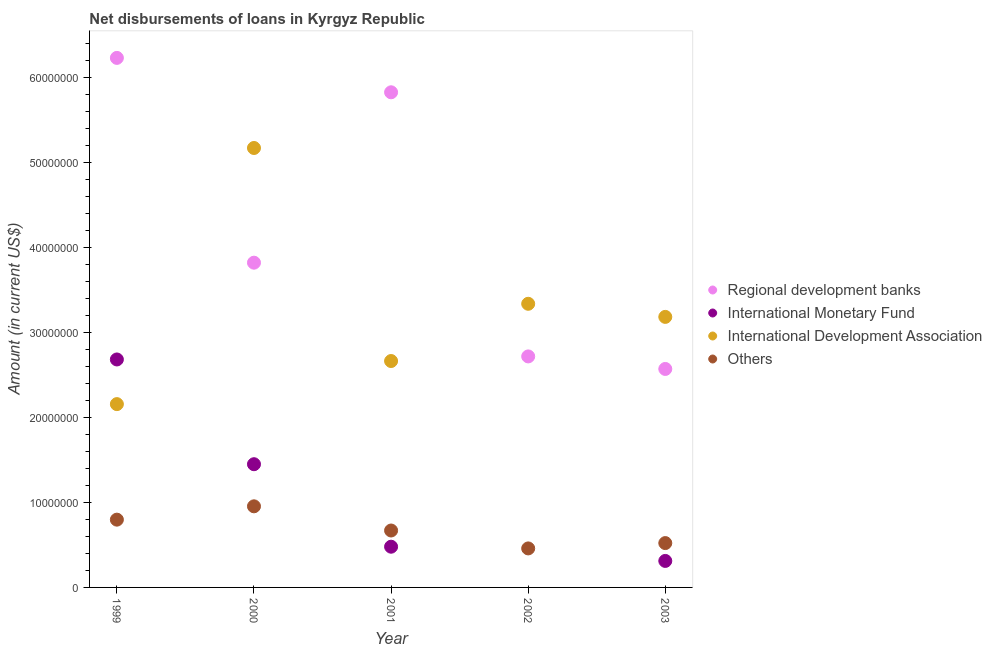What is the amount of loan disimbursed by international development association in 2002?
Ensure brevity in your answer.  3.34e+07. Across all years, what is the maximum amount of loan disimbursed by international monetary fund?
Provide a succinct answer. 2.68e+07. Across all years, what is the minimum amount of loan disimbursed by international monetary fund?
Your response must be concise. 0. What is the total amount of loan disimbursed by international development association in the graph?
Ensure brevity in your answer.  1.65e+08. What is the difference between the amount of loan disimbursed by regional development banks in 2002 and that in 2003?
Your answer should be compact. 1.48e+06. What is the difference between the amount of loan disimbursed by international monetary fund in 2001 and the amount of loan disimbursed by international development association in 2002?
Provide a succinct answer. -2.86e+07. What is the average amount of loan disimbursed by international monetary fund per year?
Keep it short and to the point. 9.85e+06. In the year 2002, what is the difference between the amount of loan disimbursed by other organisations and amount of loan disimbursed by international development association?
Your answer should be compact. -2.88e+07. What is the ratio of the amount of loan disimbursed by international development association in 2001 to that in 2003?
Your answer should be compact. 0.84. What is the difference between the highest and the second highest amount of loan disimbursed by other organisations?
Make the answer very short. 1.57e+06. What is the difference between the highest and the lowest amount of loan disimbursed by international development association?
Make the answer very short. 3.02e+07. In how many years, is the amount of loan disimbursed by international monetary fund greater than the average amount of loan disimbursed by international monetary fund taken over all years?
Your answer should be very brief. 2. Is the sum of the amount of loan disimbursed by other organisations in 1999 and 2002 greater than the maximum amount of loan disimbursed by regional development banks across all years?
Offer a very short reply. No. Does the amount of loan disimbursed by international development association monotonically increase over the years?
Give a very brief answer. No. Is the amount of loan disimbursed by international development association strictly greater than the amount of loan disimbursed by regional development banks over the years?
Offer a terse response. No. How many years are there in the graph?
Ensure brevity in your answer.  5. What is the difference between two consecutive major ticks on the Y-axis?
Provide a short and direct response. 1.00e+07. Are the values on the major ticks of Y-axis written in scientific E-notation?
Your answer should be very brief. No. Does the graph contain any zero values?
Ensure brevity in your answer.  Yes. Does the graph contain grids?
Provide a succinct answer. No. What is the title of the graph?
Keep it short and to the point. Net disbursements of loans in Kyrgyz Republic. What is the label or title of the Y-axis?
Ensure brevity in your answer.  Amount (in current US$). What is the Amount (in current US$) of Regional development banks in 1999?
Your answer should be very brief. 6.24e+07. What is the Amount (in current US$) of International Monetary Fund in 1999?
Your answer should be compact. 2.68e+07. What is the Amount (in current US$) in International Development Association in 1999?
Your answer should be compact. 2.16e+07. What is the Amount (in current US$) in Others in 1999?
Provide a short and direct response. 7.98e+06. What is the Amount (in current US$) in Regional development banks in 2000?
Provide a short and direct response. 3.82e+07. What is the Amount (in current US$) in International Monetary Fund in 2000?
Your answer should be very brief. 1.45e+07. What is the Amount (in current US$) of International Development Association in 2000?
Ensure brevity in your answer.  5.17e+07. What is the Amount (in current US$) in Others in 2000?
Your answer should be very brief. 9.55e+06. What is the Amount (in current US$) in Regional development banks in 2001?
Your answer should be very brief. 5.83e+07. What is the Amount (in current US$) in International Monetary Fund in 2001?
Make the answer very short. 4.79e+06. What is the Amount (in current US$) in International Development Association in 2001?
Provide a short and direct response. 2.67e+07. What is the Amount (in current US$) of Others in 2001?
Your response must be concise. 6.70e+06. What is the Amount (in current US$) of Regional development banks in 2002?
Make the answer very short. 2.72e+07. What is the Amount (in current US$) in International Monetary Fund in 2002?
Make the answer very short. 0. What is the Amount (in current US$) of International Development Association in 2002?
Give a very brief answer. 3.34e+07. What is the Amount (in current US$) of Others in 2002?
Provide a short and direct response. 4.59e+06. What is the Amount (in current US$) of Regional development banks in 2003?
Keep it short and to the point. 2.57e+07. What is the Amount (in current US$) in International Monetary Fund in 2003?
Give a very brief answer. 3.12e+06. What is the Amount (in current US$) in International Development Association in 2003?
Offer a terse response. 3.19e+07. What is the Amount (in current US$) of Others in 2003?
Offer a very short reply. 5.22e+06. Across all years, what is the maximum Amount (in current US$) in Regional development banks?
Give a very brief answer. 6.24e+07. Across all years, what is the maximum Amount (in current US$) of International Monetary Fund?
Provide a succinct answer. 2.68e+07. Across all years, what is the maximum Amount (in current US$) in International Development Association?
Your answer should be compact. 5.17e+07. Across all years, what is the maximum Amount (in current US$) of Others?
Ensure brevity in your answer.  9.55e+06. Across all years, what is the minimum Amount (in current US$) of Regional development banks?
Provide a short and direct response. 2.57e+07. Across all years, what is the minimum Amount (in current US$) of International Monetary Fund?
Give a very brief answer. 0. Across all years, what is the minimum Amount (in current US$) in International Development Association?
Your answer should be compact. 2.16e+07. Across all years, what is the minimum Amount (in current US$) of Others?
Offer a very short reply. 4.59e+06. What is the total Amount (in current US$) in Regional development banks in the graph?
Keep it short and to the point. 2.12e+08. What is the total Amount (in current US$) of International Monetary Fund in the graph?
Make the answer very short. 4.93e+07. What is the total Amount (in current US$) of International Development Association in the graph?
Ensure brevity in your answer.  1.65e+08. What is the total Amount (in current US$) in Others in the graph?
Give a very brief answer. 3.40e+07. What is the difference between the Amount (in current US$) of Regional development banks in 1999 and that in 2000?
Keep it short and to the point. 2.41e+07. What is the difference between the Amount (in current US$) in International Monetary Fund in 1999 and that in 2000?
Keep it short and to the point. 1.23e+07. What is the difference between the Amount (in current US$) of International Development Association in 1999 and that in 2000?
Your answer should be very brief. -3.02e+07. What is the difference between the Amount (in current US$) of Others in 1999 and that in 2000?
Give a very brief answer. -1.57e+06. What is the difference between the Amount (in current US$) of Regional development banks in 1999 and that in 2001?
Your response must be concise. 4.05e+06. What is the difference between the Amount (in current US$) of International Monetary Fund in 1999 and that in 2001?
Provide a short and direct response. 2.20e+07. What is the difference between the Amount (in current US$) of International Development Association in 1999 and that in 2001?
Ensure brevity in your answer.  -5.07e+06. What is the difference between the Amount (in current US$) of Others in 1999 and that in 2001?
Your answer should be very brief. 1.28e+06. What is the difference between the Amount (in current US$) in Regional development banks in 1999 and that in 2002?
Provide a succinct answer. 3.52e+07. What is the difference between the Amount (in current US$) of International Development Association in 1999 and that in 2002?
Give a very brief answer. -1.18e+07. What is the difference between the Amount (in current US$) of Others in 1999 and that in 2002?
Keep it short and to the point. 3.39e+06. What is the difference between the Amount (in current US$) of Regional development banks in 1999 and that in 2003?
Provide a short and direct response. 3.66e+07. What is the difference between the Amount (in current US$) in International Monetary Fund in 1999 and that in 2003?
Provide a short and direct response. 2.37e+07. What is the difference between the Amount (in current US$) in International Development Association in 1999 and that in 2003?
Give a very brief answer. -1.03e+07. What is the difference between the Amount (in current US$) in Others in 1999 and that in 2003?
Ensure brevity in your answer.  2.76e+06. What is the difference between the Amount (in current US$) of Regional development banks in 2000 and that in 2001?
Give a very brief answer. -2.01e+07. What is the difference between the Amount (in current US$) of International Monetary Fund in 2000 and that in 2001?
Your response must be concise. 9.71e+06. What is the difference between the Amount (in current US$) in International Development Association in 2000 and that in 2001?
Offer a terse response. 2.51e+07. What is the difference between the Amount (in current US$) in Others in 2000 and that in 2001?
Ensure brevity in your answer.  2.85e+06. What is the difference between the Amount (in current US$) of Regional development banks in 2000 and that in 2002?
Your response must be concise. 1.10e+07. What is the difference between the Amount (in current US$) of International Development Association in 2000 and that in 2002?
Give a very brief answer. 1.83e+07. What is the difference between the Amount (in current US$) of Others in 2000 and that in 2002?
Provide a succinct answer. 4.96e+06. What is the difference between the Amount (in current US$) in Regional development banks in 2000 and that in 2003?
Your response must be concise. 1.25e+07. What is the difference between the Amount (in current US$) of International Monetary Fund in 2000 and that in 2003?
Your answer should be compact. 1.14e+07. What is the difference between the Amount (in current US$) of International Development Association in 2000 and that in 2003?
Your answer should be very brief. 1.99e+07. What is the difference between the Amount (in current US$) in Others in 2000 and that in 2003?
Provide a succinct answer. 4.33e+06. What is the difference between the Amount (in current US$) in Regional development banks in 2001 and that in 2002?
Give a very brief answer. 3.11e+07. What is the difference between the Amount (in current US$) of International Development Association in 2001 and that in 2002?
Make the answer very short. -6.74e+06. What is the difference between the Amount (in current US$) of Others in 2001 and that in 2002?
Your answer should be compact. 2.11e+06. What is the difference between the Amount (in current US$) in Regional development banks in 2001 and that in 2003?
Provide a short and direct response. 3.26e+07. What is the difference between the Amount (in current US$) in International Monetary Fund in 2001 and that in 2003?
Give a very brief answer. 1.67e+06. What is the difference between the Amount (in current US$) in International Development Association in 2001 and that in 2003?
Offer a very short reply. -5.20e+06. What is the difference between the Amount (in current US$) in Others in 2001 and that in 2003?
Provide a short and direct response. 1.48e+06. What is the difference between the Amount (in current US$) of Regional development banks in 2002 and that in 2003?
Offer a very short reply. 1.48e+06. What is the difference between the Amount (in current US$) of International Development Association in 2002 and that in 2003?
Give a very brief answer. 1.54e+06. What is the difference between the Amount (in current US$) of Others in 2002 and that in 2003?
Give a very brief answer. -6.28e+05. What is the difference between the Amount (in current US$) in Regional development banks in 1999 and the Amount (in current US$) in International Monetary Fund in 2000?
Offer a terse response. 4.78e+07. What is the difference between the Amount (in current US$) of Regional development banks in 1999 and the Amount (in current US$) of International Development Association in 2000?
Make the answer very short. 1.06e+07. What is the difference between the Amount (in current US$) of Regional development banks in 1999 and the Amount (in current US$) of Others in 2000?
Offer a very short reply. 5.28e+07. What is the difference between the Amount (in current US$) in International Monetary Fund in 1999 and the Amount (in current US$) in International Development Association in 2000?
Provide a short and direct response. -2.49e+07. What is the difference between the Amount (in current US$) of International Monetary Fund in 1999 and the Amount (in current US$) of Others in 2000?
Provide a short and direct response. 1.73e+07. What is the difference between the Amount (in current US$) of International Development Association in 1999 and the Amount (in current US$) of Others in 2000?
Give a very brief answer. 1.20e+07. What is the difference between the Amount (in current US$) of Regional development banks in 1999 and the Amount (in current US$) of International Monetary Fund in 2001?
Your answer should be very brief. 5.76e+07. What is the difference between the Amount (in current US$) of Regional development banks in 1999 and the Amount (in current US$) of International Development Association in 2001?
Your answer should be compact. 3.57e+07. What is the difference between the Amount (in current US$) of Regional development banks in 1999 and the Amount (in current US$) of Others in 2001?
Provide a succinct answer. 5.56e+07. What is the difference between the Amount (in current US$) in International Monetary Fund in 1999 and the Amount (in current US$) in International Development Association in 2001?
Ensure brevity in your answer.  1.84e+05. What is the difference between the Amount (in current US$) of International Monetary Fund in 1999 and the Amount (in current US$) of Others in 2001?
Provide a short and direct response. 2.01e+07. What is the difference between the Amount (in current US$) of International Development Association in 1999 and the Amount (in current US$) of Others in 2001?
Offer a terse response. 1.49e+07. What is the difference between the Amount (in current US$) of Regional development banks in 1999 and the Amount (in current US$) of International Development Association in 2002?
Provide a succinct answer. 2.90e+07. What is the difference between the Amount (in current US$) in Regional development banks in 1999 and the Amount (in current US$) in Others in 2002?
Offer a very short reply. 5.78e+07. What is the difference between the Amount (in current US$) of International Monetary Fund in 1999 and the Amount (in current US$) of International Development Association in 2002?
Your response must be concise. -6.56e+06. What is the difference between the Amount (in current US$) in International Monetary Fund in 1999 and the Amount (in current US$) in Others in 2002?
Provide a succinct answer. 2.22e+07. What is the difference between the Amount (in current US$) in International Development Association in 1999 and the Amount (in current US$) in Others in 2002?
Provide a succinct answer. 1.70e+07. What is the difference between the Amount (in current US$) of Regional development banks in 1999 and the Amount (in current US$) of International Monetary Fund in 2003?
Give a very brief answer. 5.92e+07. What is the difference between the Amount (in current US$) of Regional development banks in 1999 and the Amount (in current US$) of International Development Association in 2003?
Keep it short and to the point. 3.05e+07. What is the difference between the Amount (in current US$) in Regional development banks in 1999 and the Amount (in current US$) in Others in 2003?
Give a very brief answer. 5.71e+07. What is the difference between the Amount (in current US$) in International Monetary Fund in 1999 and the Amount (in current US$) in International Development Association in 2003?
Offer a very short reply. -5.01e+06. What is the difference between the Amount (in current US$) of International Monetary Fund in 1999 and the Amount (in current US$) of Others in 2003?
Your response must be concise. 2.16e+07. What is the difference between the Amount (in current US$) of International Development Association in 1999 and the Amount (in current US$) of Others in 2003?
Offer a terse response. 1.64e+07. What is the difference between the Amount (in current US$) in Regional development banks in 2000 and the Amount (in current US$) in International Monetary Fund in 2001?
Ensure brevity in your answer.  3.34e+07. What is the difference between the Amount (in current US$) of Regional development banks in 2000 and the Amount (in current US$) of International Development Association in 2001?
Give a very brief answer. 1.16e+07. What is the difference between the Amount (in current US$) of Regional development banks in 2000 and the Amount (in current US$) of Others in 2001?
Provide a short and direct response. 3.15e+07. What is the difference between the Amount (in current US$) of International Monetary Fund in 2000 and the Amount (in current US$) of International Development Association in 2001?
Provide a short and direct response. -1.22e+07. What is the difference between the Amount (in current US$) in International Monetary Fund in 2000 and the Amount (in current US$) in Others in 2001?
Provide a succinct answer. 7.81e+06. What is the difference between the Amount (in current US$) in International Development Association in 2000 and the Amount (in current US$) in Others in 2001?
Give a very brief answer. 4.50e+07. What is the difference between the Amount (in current US$) in Regional development banks in 2000 and the Amount (in current US$) in International Development Association in 2002?
Offer a terse response. 4.84e+06. What is the difference between the Amount (in current US$) of Regional development banks in 2000 and the Amount (in current US$) of Others in 2002?
Your response must be concise. 3.36e+07. What is the difference between the Amount (in current US$) of International Monetary Fund in 2000 and the Amount (in current US$) of International Development Association in 2002?
Make the answer very short. -1.89e+07. What is the difference between the Amount (in current US$) in International Monetary Fund in 2000 and the Amount (in current US$) in Others in 2002?
Your answer should be very brief. 9.92e+06. What is the difference between the Amount (in current US$) of International Development Association in 2000 and the Amount (in current US$) of Others in 2002?
Your response must be concise. 4.72e+07. What is the difference between the Amount (in current US$) in Regional development banks in 2000 and the Amount (in current US$) in International Monetary Fund in 2003?
Your answer should be very brief. 3.51e+07. What is the difference between the Amount (in current US$) of Regional development banks in 2000 and the Amount (in current US$) of International Development Association in 2003?
Make the answer very short. 6.38e+06. What is the difference between the Amount (in current US$) in Regional development banks in 2000 and the Amount (in current US$) in Others in 2003?
Offer a very short reply. 3.30e+07. What is the difference between the Amount (in current US$) in International Monetary Fund in 2000 and the Amount (in current US$) in International Development Association in 2003?
Your answer should be compact. -1.73e+07. What is the difference between the Amount (in current US$) of International Monetary Fund in 2000 and the Amount (in current US$) of Others in 2003?
Give a very brief answer. 9.29e+06. What is the difference between the Amount (in current US$) in International Development Association in 2000 and the Amount (in current US$) in Others in 2003?
Your response must be concise. 4.65e+07. What is the difference between the Amount (in current US$) in Regional development banks in 2001 and the Amount (in current US$) in International Development Association in 2002?
Your answer should be very brief. 2.49e+07. What is the difference between the Amount (in current US$) in Regional development banks in 2001 and the Amount (in current US$) in Others in 2002?
Ensure brevity in your answer.  5.37e+07. What is the difference between the Amount (in current US$) of International Monetary Fund in 2001 and the Amount (in current US$) of International Development Association in 2002?
Offer a very short reply. -2.86e+07. What is the difference between the Amount (in current US$) in International Monetary Fund in 2001 and the Amount (in current US$) in Others in 2002?
Offer a terse response. 2.01e+05. What is the difference between the Amount (in current US$) of International Development Association in 2001 and the Amount (in current US$) of Others in 2002?
Provide a short and direct response. 2.21e+07. What is the difference between the Amount (in current US$) of Regional development banks in 2001 and the Amount (in current US$) of International Monetary Fund in 2003?
Make the answer very short. 5.52e+07. What is the difference between the Amount (in current US$) in Regional development banks in 2001 and the Amount (in current US$) in International Development Association in 2003?
Provide a succinct answer. 2.64e+07. What is the difference between the Amount (in current US$) in Regional development banks in 2001 and the Amount (in current US$) in Others in 2003?
Keep it short and to the point. 5.31e+07. What is the difference between the Amount (in current US$) in International Monetary Fund in 2001 and the Amount (in current US$) in International Development Association in 2003?
Ensure brevity in your answer.  -2.71e+07. What is the difference between the Amount (in current US$) of International Monetary Fund in 2001 and the Amount (in current US$) of Others in 2003?
Offer a very short reply. -4.27e+05. What is the difference between the Amount (in current US$) of International Development Association in 2001 and the Amount (in current US$) of Others in 2003?
Provide a succinct answer. 2.14e+07. What is the difference between the Amount (in current US$) in Regional development banks in 2002 and the Amount (in current US$) in International Monetary Fund in 2003?
Your answer should be compact. 2.41e+07. What is the difference between the Amount (in current US$) of Regional development banks in 2002 and the Amount (in current US$) of International Development Association in 2003?
Your response must be concise. -4.65e+06. What is the difference between the Amount (in current US$) in Regional development banks in 2002 and the Amount (in current US$) in Others in 2003?
Your answer should be very brief. 2.20e+07. What is the difference between the Amount (in current US$) in International Development Association in 2002 and the Amount (in current US$) in Others in 2003?
Give a very brief answer. 2.82e+07. What is the average Amount (in current US$) of Regional development banks per year?
Your answer should be very brief. 4.24e+07. What is the average Amount (in current US$) in International Monetary Fund per year?
Your answer should be very brief. 9.85e+06. What is the average Amount (in current US$) in International Development Association per year?
Offer a very short reply. 3.30e+07. What is the average Amount (in current US$) of Others per year?
Ensure brevity in your answer.  6.81e+06. In the year 1999, what is the difference between the Amount (in current US$) of Regional development banks and Amount (in current US$) of International Monetary Fund?
Your response must be concise. 3.55e+07. In the year 1999, what is the difference between the Amount (in current US$) in Regional development banks and Amount (in current US$) in International Development Association?
Provide a succinct answer. 4.08e+07. In the year 1999, what is the difference between the Amount (in current US$) of Regional development banks and Amount (in current US$) of Others?
Your response must be concise. 5.44e+07. In the year 1999, what is the difference between the Amount (in current US$) in International Monetary Fund and Amount (in current US$) in International Development Association?
Offer a terse response. 5.26e+06. In the year 1999, what is the difference between the Amount (in current US$) of International Monetary Fund and Amount (in current US$) of Others?
Give a very brief answer. 1.89e+07. In the year 1999, what is the difference between the Amount (in current US$) in International Development Association and Amount (in current US$) in Others?
Provide a short and direct response. 1.36e+07. In the year 2000, what is the difference between the Amount (in current US$) of Regional development banks and Amount (in current US$) of International Monetary Fund?
Keep it short and to the point. 2.37e+07. In the year 2000, what is the difference between the Amount (in current US$) in Regional development banks and Amount (in current US$) in International Development Association?
Ensure brevity in your answer.  -1.35e+07. In the year 2000, what is the difference between the Amount (in current US$) in Regional development banks and Amount (in current US$) in Others?
Your answer should be compact. 2.87e+07. In the year 2000, what is the difference between the Amount (in current US$) of International Monetary Fund and Amount (in current US$) of International Development Association?
Provide a short and direct response. -3.72e+07. In the year 2000, what is the difference between the Amount (in current US$) in International Monetary Fund and Amount (in current US$) in Others?
Ensure brevity in your answer.  4.96e+06. In the year 2000, what is the difference between the Amount (in current US$) of International Development Association and Amount (in current US$) of Others?
Make the answer very short. 4.22e+07. In the year 2001, what is the difference between the Amount (in current US$) in Regional development banks and Amount (in current US$) in International Monetary Fund?
Keep it short and to the point. 5.35e+07. In the year 2001, what is the difference between the Amount (in current US$) of Regional development banks and Amount (in current US$) of International Development Association?
Your answer should be compact. 3.16e+07. In the year 2001, what is the difference between the Amount (in current US$) of Regional development banks and Amount (in current US$) of Others?
Offer a terse response. 5.16e+07. In the year 2001, what is the difference between the Amount (in current US$) of International Monetary Fund and Amount (in current US$) of International Development Association?
Provide a short and direct response. -2.19e+07. In the year 2001, what is the difference between the Amount (in current US$) of International Monetary Fund and Amount (in current US$) of Others?
Make the answer very short. -1.91e+06. In the year 2001, what is the difference between the Amount (in current US$) in International Development Association and Amount (in current US$) in Others?
Your answer should be compact. 2.00e+07. In the year 2002, what is the difference between the Amount (in current US$) of Regional development banks and Amount (in current US$) of International Development Association?
Provide a short and direct response. -6.20e+06. In the year 2002, what is the difference between the Amount (in current US$) of Regional development banks and Amount (in current US$) of Others?
Offer a very short reply. 2.26e+07. In the year 2002, what is the difference between the Amount (in current US$) of International Development Association and Amount (in current US$) of Others?
Ensure brevity in your answer.  2.88e+07. In the year 2003, what is the difference between the Amount (in current US$) of Regional development banks and Amount (in current US$) of International Monetary Fund?
Offer a terse response. 2.26e+07. In the year 2003, what is the difference between the Amount (in current US$) of Regional development banks and Amount (in current US$) of International Development Association?
Provide a short and direct response. -6.13e+06. In the year 2003, what is the difference between the Amount (in current US$) of Regional development banks and Amount (in current US$) of Others?
Provide a short and direct response. 2.05e+07. In the year 2003, what is the difference between the Amount (in current US$) of International Monetary Fund and Amount (in current US$) of International Development Association?
Your answer should be very brief. -2.87e+07. In the year 2003, what is the difference between the Amount (in current US$) in International Monetary Fund and Amount (in current US$) in Others?
Ensure brevity in your answer.  -2.10e+06. In the year 2003, what is the difference between the Amount (in current US$) of International Development Association and Amount (in current US$) of Others?
Offer a terse response. 2.66e+07. What is the ratio of the Amount (in current US$) in Regional development banks in 1999 to that in 2000?
Provide a short and direct response. 1.63. What is the ratio of the Amount (in current US$) in International Monetary Fund in 1999 to that in 2000?
Give a very brief answer. 1.85. What is the ratio of the Amount (in current US$) in International Development Association in 1999 to that in 2000?
Provide a succinct answer. 0.42. What is the ratio of the Amount (in current US$) in Others in 1999 to that in 2000?
Offer a very short reply. 0.84. What is the ratio of the Amount (in current US$) in Regional development banks in 1999 to that in 2001?
Your answer should be very brief. 1.07. What is the ratio of the Amount (in current US$) of International Monetary Fund in 1999 to that in 2001?
Your response must be concise. 5.6. What is the ratio of the Amount (in current US$) of International Development Association in 1999 to that in 2001?
Provide a succinct answer. 0.81. What is the ratio of the Amount (in current US$) in Others in 1999 to that in 2001?
Ensure brevity in your answer.  1.19. What is the ratio of the Amount (in current US$) in Regional development banks in 1999 to that in 2002?
Keep it short and to the point. 2.29. What is the ratio of the Amount (in current US$) in International Development Association in 1999 to that in 2002?
Keep it short and to the point. 0.65. What is the ratio of the Amount (in current US$) of Others in 1999 to that in 2002?
Give a very brief answer. 1.74. What is the ratio of the Amount (in current US$) of Regional development banks in 1999 to that in 2003?
Provide a succinct answer. 2.42. What is the ratio of the Amount (in current US$) in International Monetary Fund in 1999 to that in 2003?
Make the answer very short. 8.6. What is the ratio of the Amount (in current US$) in International Development Association in 1999 to that in 2003?
Your answer should be very brief. 0.68. What is the ratio of the Amount (in current US$) of Others in 1999 to that in 2003?
Give a very brief answer. 1.53. What is the ratio of the Amount (in current US$) in Regional development banks in 2000 to that in 2001?
Keep it short and to the point. 0.66. What is the ratio of the Amount (in current US$) of International Monetary Fund in 2000 to that in 2001?
Provide a short and direct response. 3.03. What is the ratio of the Amount (in current US$) in International Development Association in 2000 to that in 2001?
Ensure brevity in your answer.  1.94. What is the ratio of the Amount (in current US$) in Others in 2000 to that in 2001?
Ensure brevity in your answer.  1.42. What is the ratio of the Amount (in current US$) in Regional development banks in 2000 to that in 2002?
Make the answer very short. 1.41. What is the ratio of the Amount (in current US$) of International Development Association in 2000 to that in 2002?
Keep it short and to the point. 1.55. What is the ratio of the Amount (in current US$) in Others in 2000 to that in 2002?
Offer a very short reply. 2.08. What is the ratio of the Amount (in current US$) in Regional development banks in 2000 to that in 2003?
Provide a short and direct response. 1.49. What is the ratio of the Amount (in current US$) in International Monetary Fund in 2000 to that in 2003?
Give a very brief answer. 4.65. What is the ratio of the Amount (in current US$) in International Development Association in 2000 to that in 2003?
Your answer should be very brief. 1.62. What is the ratio of the Amount (in current US$) in Others in 2000 to that in 2003?
Ensure brevity in your answer.  1.83. What is the ratio of the Amount (in current US$) of Regional development banks in 2001 to that in 2002?
Keep it short and to the point. 2.14. What is the ratio of the Amount (in current US$) in International Development Association in 2001 to that in 2002?
Keep it short and to the point. 0.8. What is the ratio of the Amount (in current US$) of Others in 2001 to that in 2002?
Provide a short and direct response. 1.46. What is the ratio of the Amount (in current US$) in Regional development banks in 2001 to that in 2003?
Offer a terse response. 2.27. What is the ratio of the Amount (in current US$) of International Monetary Fund in 2001 to that in 2003?
Offer a terse response. 1.54. What is the ratio of the Amount (in current US$) in International Development Association in 2001 to that in 2003?
Ensure brevity in your answer.  0.84. What is the ratio of the Amount (in current US$) of Others in 2001 to that in 2003?
Your answer should be very brief. 1.28. What is the ratio of the Amount (in current US$) in Regional development banks in 2002 to that in 2003?
Keep it short and to the point. 1.06. What is the ratio of the Amount (in current US$) in International Development Association in 2002 to that in 2003?
Keep it short and to the point. 1.05. What is the ratio of the Amount (in current US$) in Others in 2002 to that in 2003?
Offer a very short reply. 0.88. What is the difference between the highest and the second highest Amount (in current US$) of Regional development banks?
Make the answer very short. 4.05e+06. What is the difference between the highest and the second highest Amount (in current US$) of International Monetary Fund?
Give a very brief answer. 1.23e+07. What is the difference between the highest and the second highest Amount (in current US$) of International Development Association?
Make the answer very short. 1.83e+07. What is the difference between the highest and the second highest Amount (in current US$) of Others?
Ensure brevity in your answer.  1.57e+06. What is the difference between the highest and the lowest Amount (in current US$) in Regional development banks?
Your answer should be compact. 3.66e+07. What is the difference between the highest and the lowest Amount (in current US$) of International Monetary Fund?
Make the answer very short. 2.68e+07. What is the difference between the highest and the lowest Amount (in current US$) of International Development Association?
Provide a succinct answer. 3.02e+07. What is the difference between the highest and the lowest Amount (in current US$) in Others?
Provide a succinct answer. 4.96e+06. 